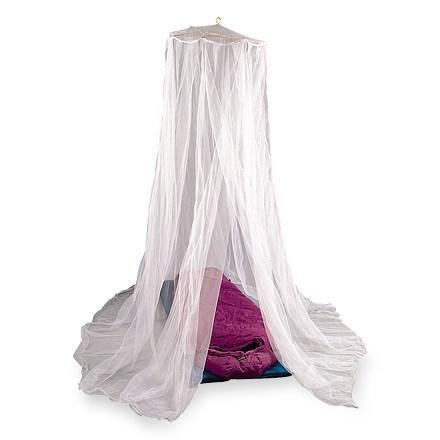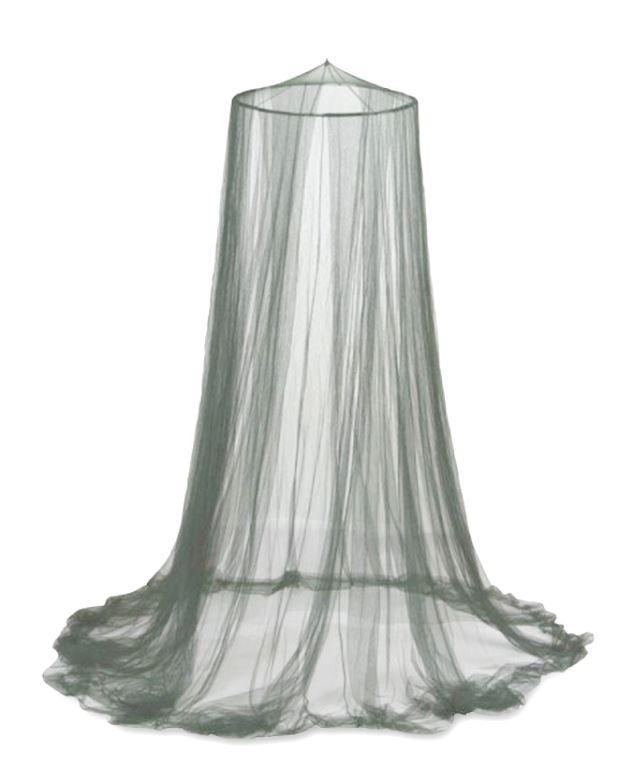The first image is the image on the left, the second image is the image on the right. Assess this claim about the two images: "There are two canopies and at least one is green a square.". Correct or not? Answer yes or no. No. The first image is the image on the left, the second image is the image on the right. Assess this claim about the two images: "Green netting hangs over two cots in one of the images.". Correct or not? Answer yes or no. No. 